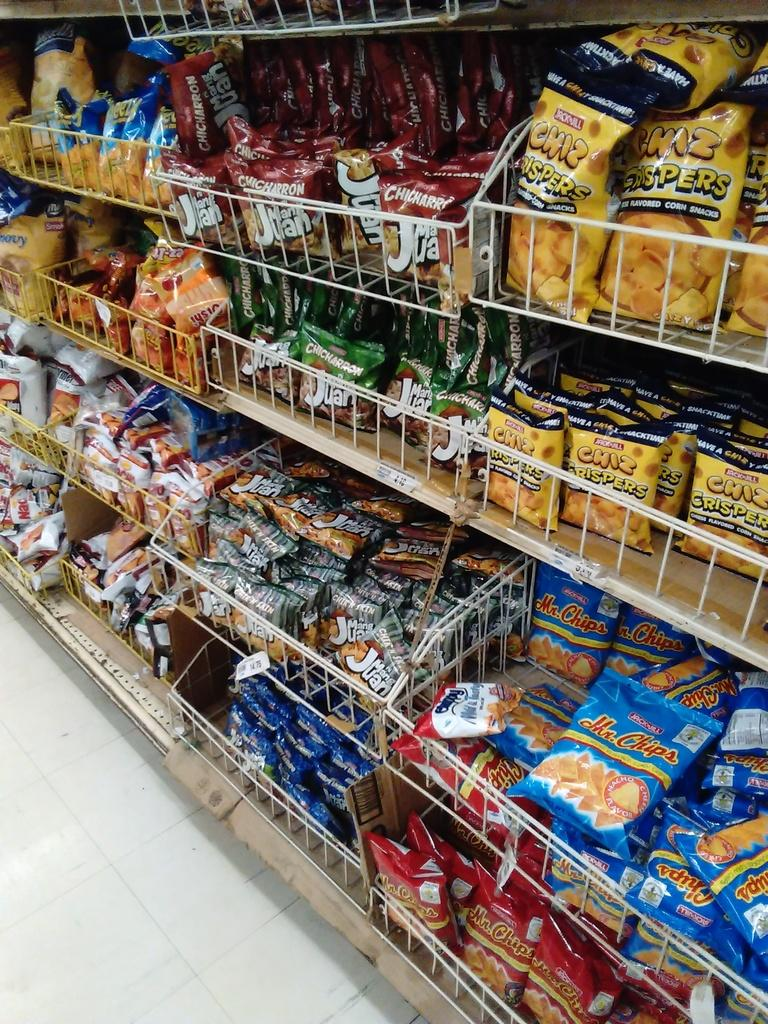<image>
Summarize the visual content of the image. Store aisle that shows some Mr. Chips in the shelf. 